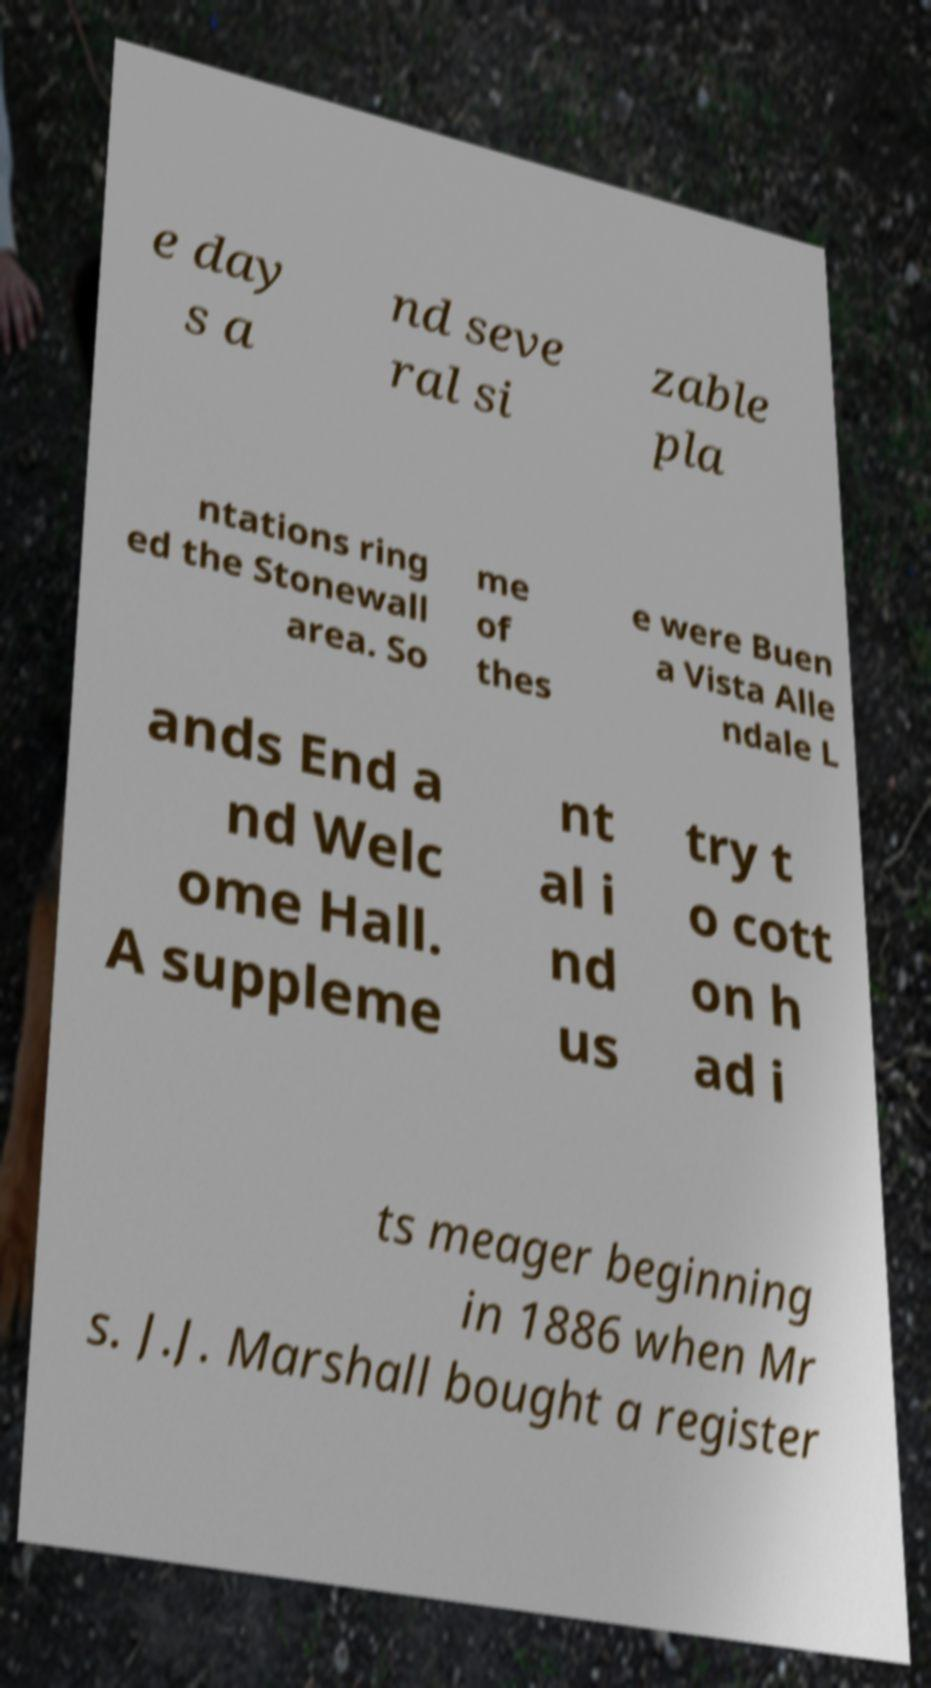I need the written content from this picture converted into text. Can you do that? e day s a nd seve ral si zable pla ntations ring ed the Stonewall area. So me of thes e were Buen a Vista Alle ndale L ands End a nd Welc ome Hall. A suppleme nt al i nd us try t o cott on h ad i ts meager beginning in 1886 when Mr s. J.J. Marshall bought a register 